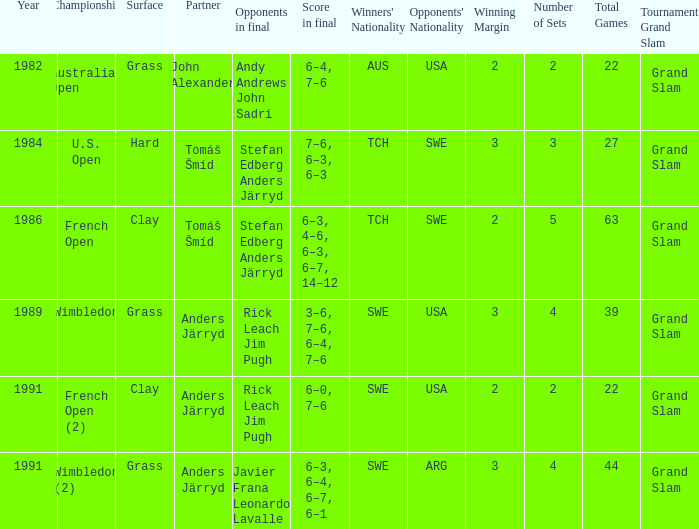What was the surface when he played with John Alexander?  Grass. 